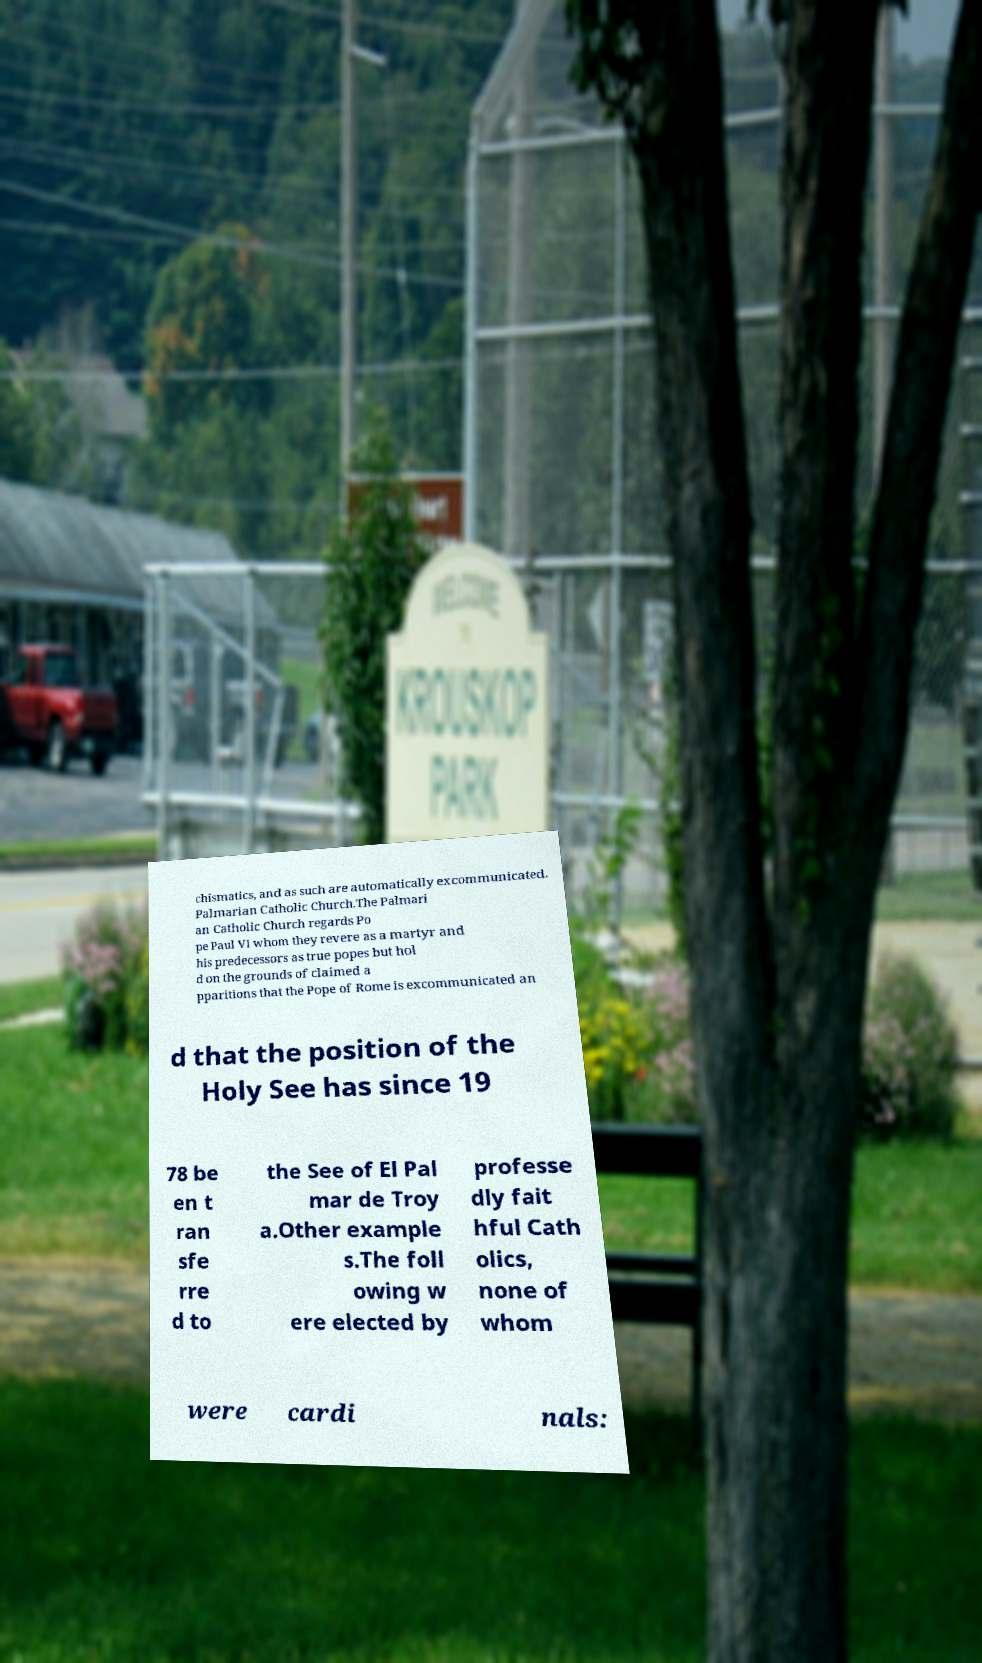There's text embedded in this image that I need extracted. Can you transcribe it verbatim? chismatics, and as such are automatically excommunicated. Palmarian Catholic Church.The Palmari an Catholic Church regards Po pe Paul VI whom they revere as a martyr and his predecessors as true popes but hol d on the grounds of claimed a pparitions that the Pope of Rome is excommunicated an d that the position of the Holy See has since 19 78 be en t ran sfe rre d to the See of El Pal mar de Troy a.Other example s.The foll owing w ere elected by professe dly fait hful Cath olics, none of whom were cardi nals: 